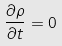<formula> <loc_0><loc_0><loc_500><loc_500>\frac { \partial \rho } { \partial t } = 0</formula> 